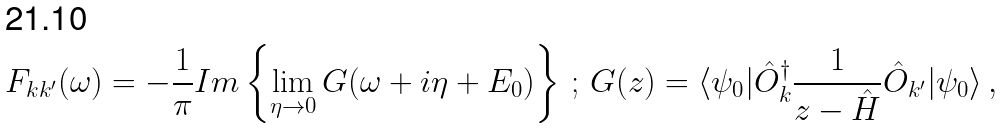Convert formula to latex. <formula><loc_0><loc_0><loc_500><loc_500>F _ { k k ^ { \prime } } ( \omega ) = - \frac { 1 } { \pi } I m \left \{ \lim _ { \eta \to 0 } G ( \omega + i \eta + E _ { 0 } ) \right \} \, ; \, G ( z ) = \langle \psi _ { 0 } | \hat { O } _ { k } ^ { \dagger } \frac { 1 } { z - \hat { H } } \hat { O } _ { k ^ { \prime } } | \psi _ { 0 } \rangle \, ,</formula> 